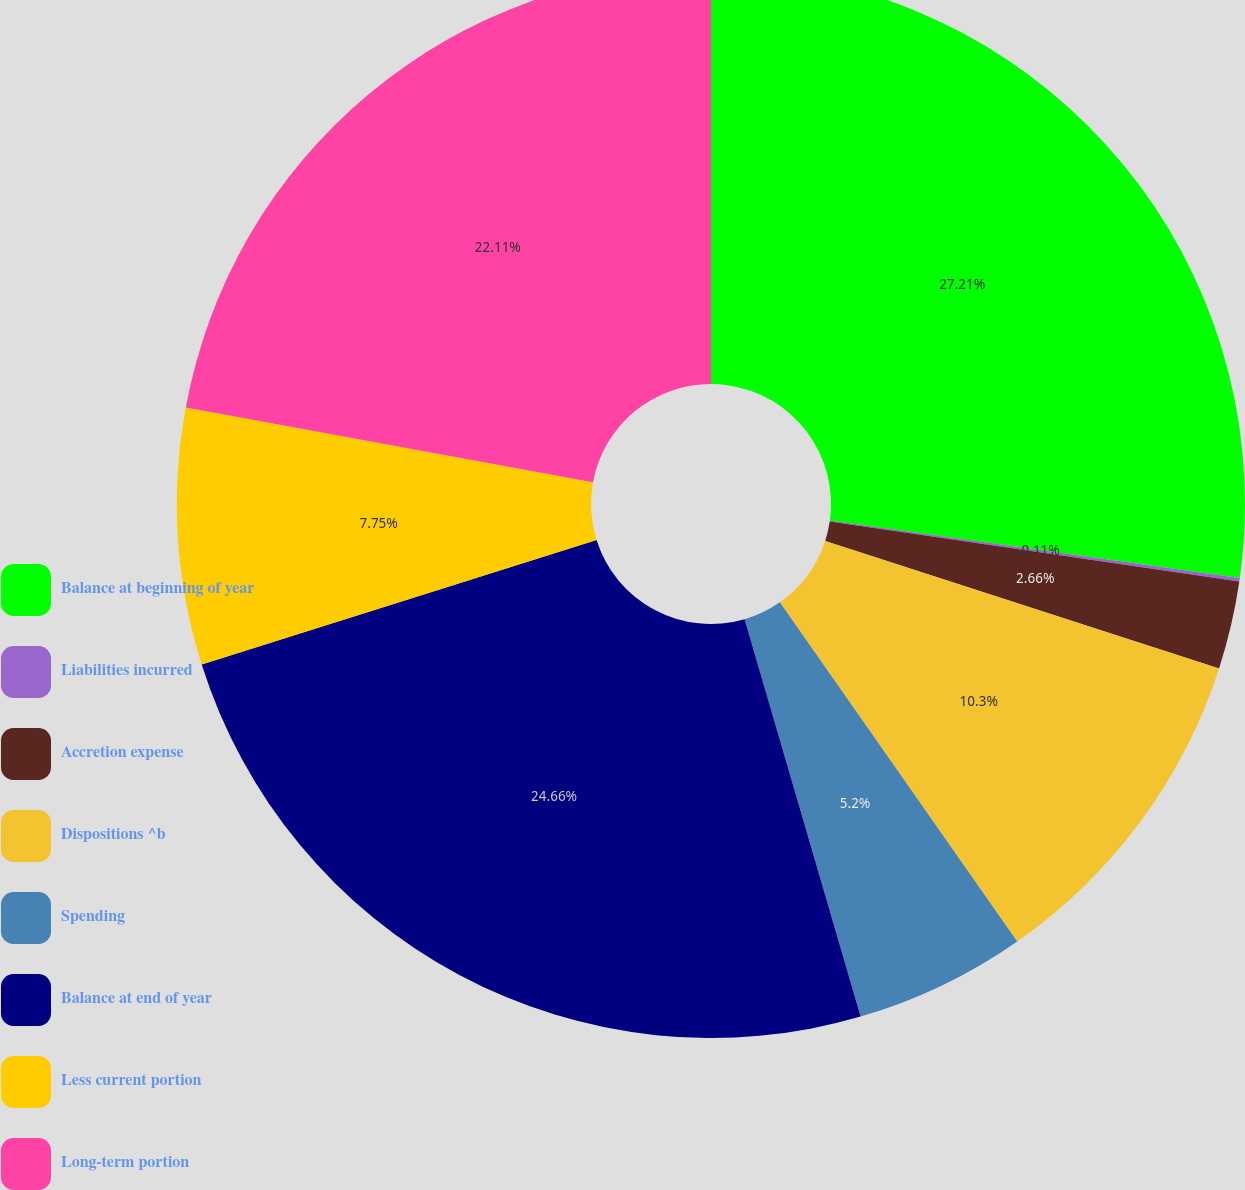Convert chart to OTSL. <chart><loc_0><loc_0><loc_500><loc_500><pie_chart><fcel>Balance at beginning of year<fcel>Liabilities incurred<fcel>Accretion expense<fcel>Dispositions ^b<fcel>Spending<fcel>Balance at end of year<fcel>Less current portion<fcel>Long-term portion<nl><fcel>27.21%<fcel>0.11%<fcel>2.66%<fcel>10.3%<fcel>5.2%<fcel>24.66%<fcel>7.75%<fcel>22.11%<nl></chart> 